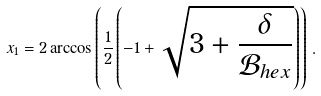<formula> <loc_0><loc_0><loc_500><loc_500>x _ { 1 } = 2 \arccos \left ( \frac { 1 } { 2 } \left ( - 1 + \sqrt { 3 + \frac { \delta } { \mathcal { B } _ { h e x } } } \right ) \right ) \, .</formula> 